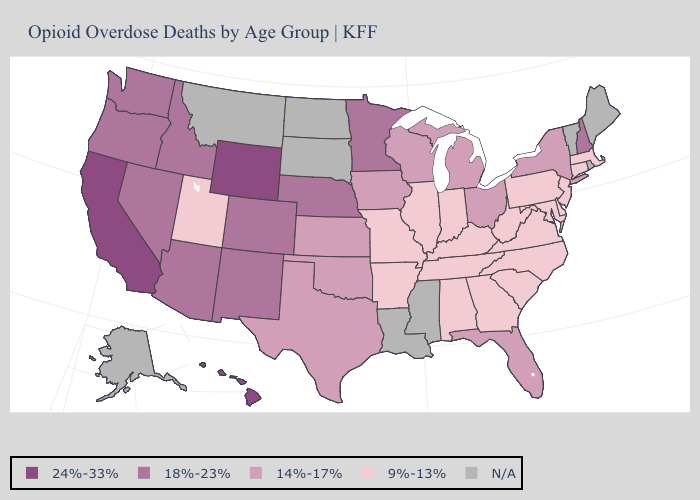Which states have the lowest value in the USA?
Keep it brief. Alabama, Arkansas, Connecticut, Delaware, Georgia, Illinois, Indiana, Kentucky, Maryland, Massachusetts, Missouri, New Jersey, North Carolina, Pennsylvania, South Carolina, Tennessee, Utah, Virginia, West Virginia. Does the first symbol in the legend represent the smallest category?
Write a very short answer. No. Name the states that have a value in the range 14%-17%?
Concise answer only. Florida, Iowa, Kansas, Michigan, New York, Ohio, Oklahoma, Texas, Wisconsin. Does Missouri have the lowest value in the MidWest?
Answer briefly. Yes. Name the states that have a value in the range 14%-17%?
Short answer required. Florida, Iowa, Kansas, Michigan, New York, Ohio, Oklahoma, Texas, Wisconsin. What is the lowest value in the Northeast?
Give a very brief answer. 9%-13%. What is the value of Ohio?
Answer briefly. 14%-17%. What is the highest value in states that border Iowa?
Answer briefly. 18%-23%. Does Wisconsin have the lowest value in the USA?
Concise answer only. No. Which states have the highest value in the USA?
Concise answer only. California, Hawaii, Wyoming. What is the value of Vermont?
Keep it brief. N/A. Among the states that border Delaware , which have the highest value?
Concise answer only. Maryland, New Jersey, Pennsylvania. Name the states that have a value in the range 18%-23%?
Give a very brief answer. Arizona, Colorado, Idaho, Minnesota, Nebraska, Nevada, New Hampshire, New Mexico, Oregon, Washington. What is the value of Alaska?
Answer briefly. N/A. Does the map have missing data?
Quick response, please. Yes. 